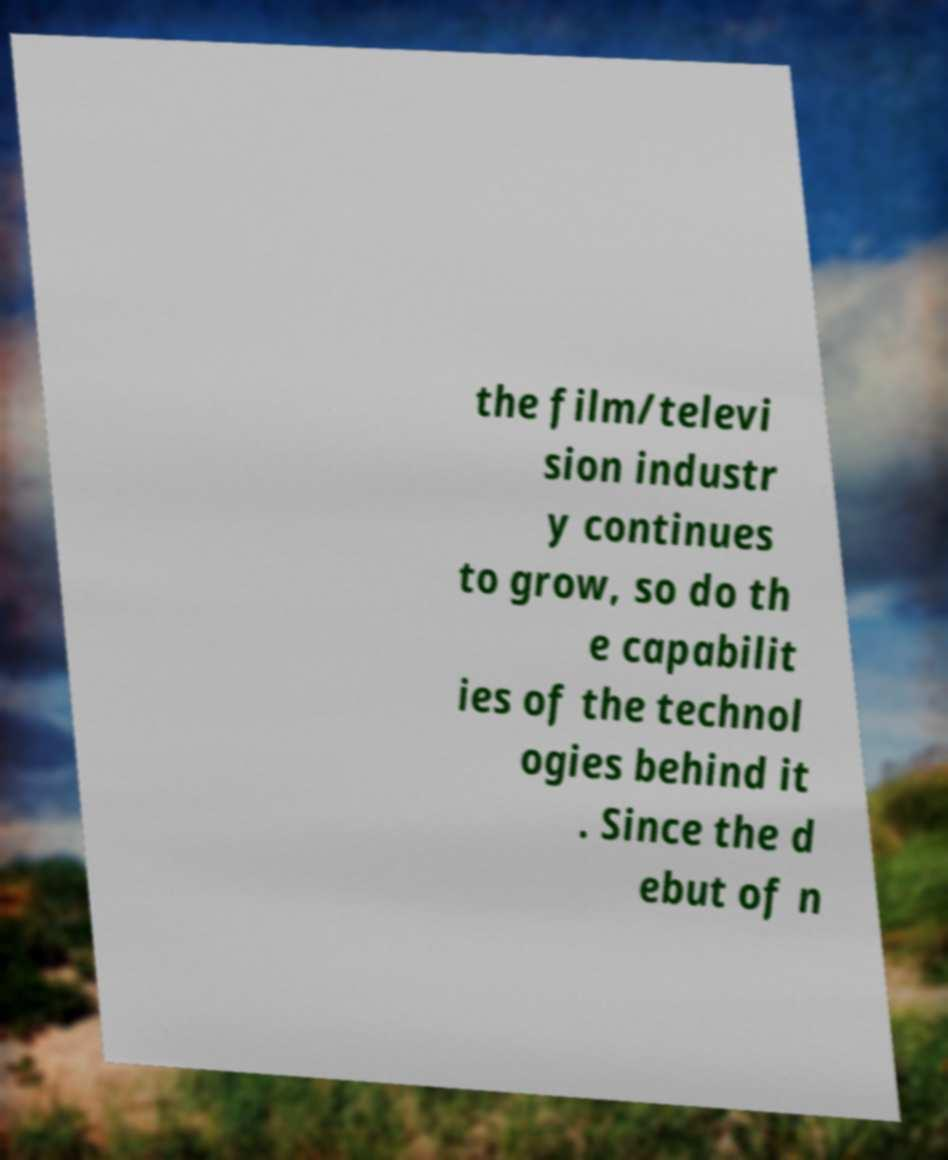For documentation purposes, I need the text within this image transcribed. Could you provide that? the film/televi sion industr y continues to grow, so do th e capabilit ies of the technol ogies behind it . Since the d ebut of n 